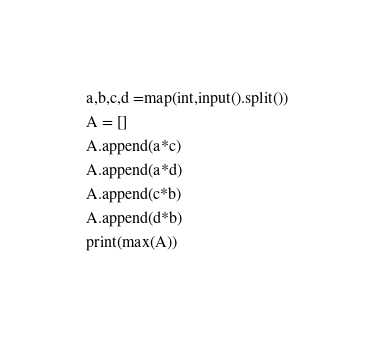Convert code to text. <code><loc_0><loc_0><loc_500><loc_500><_Python_>a,b,c,d =map(int,input().split())
A = []
A.append(a*c)
A.append(a*d)
A.append(c*b)
A.append(d*b)
print(max(A))</code> 